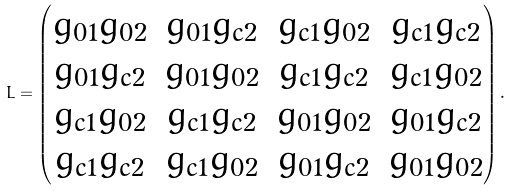<formula> <loc_0><loc_0><loc_500><loc_500>L = \begin{pmatrix} g _ { 0 1 } g _ { 0 2 } & g _ { 0 1 } g _ { c 2 } & g _ { c 1 } g _ { 0 2 } & g _ { c 1 } g _ { c 2 } \\ g _ { 0 1 } g _ { c 2 } & g _ { 0 1 } g _ { 0 2 } & g _ { c 1 } g _ { c 2 } & g _ { c 1 } g _ { 0 2 } \\ g _ { c 1 } g _ { 0 2 } & g _ { c 1 } g _ { c 2 } & g _ { 0 1 } g _ { 0 2 } & g _ { 0 1 } g _ { c 2 } \\ g _ { c 1 } g _ { c 2 } & g _ { c 1 } g _ { 0 2 } & g _ { 0 1 } g _ { c 2 } & g _ { 0 1 } g _ { 0 2 } \\ \end{pmatrix} .</formula> 